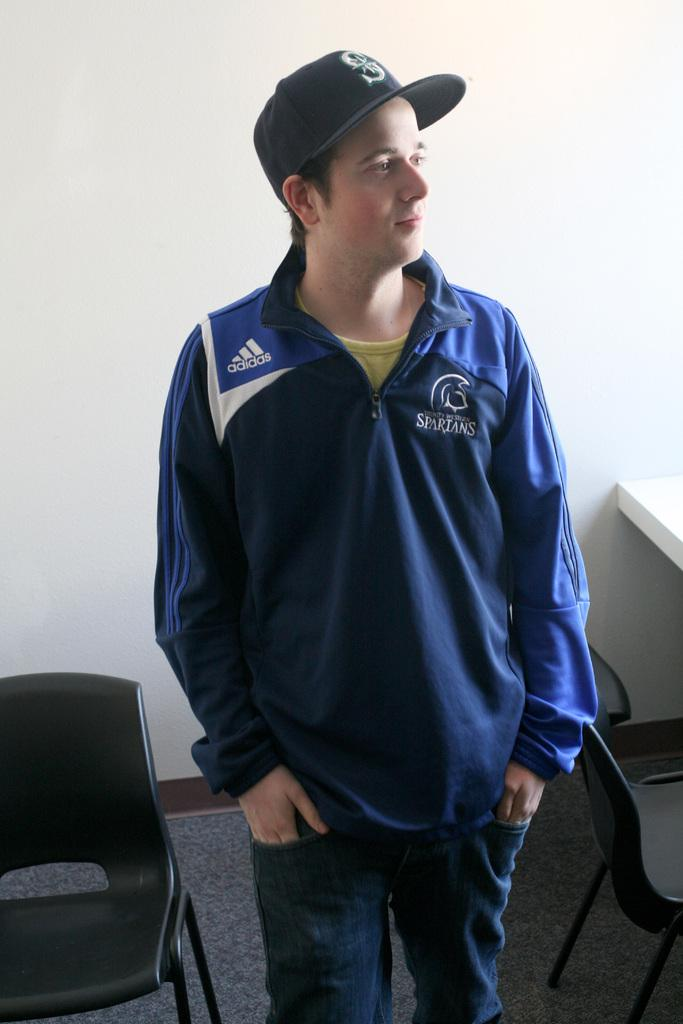<image>
Share a concise interpretation of the image provided. A person wearing a Spartans jacket made by Adidas. 